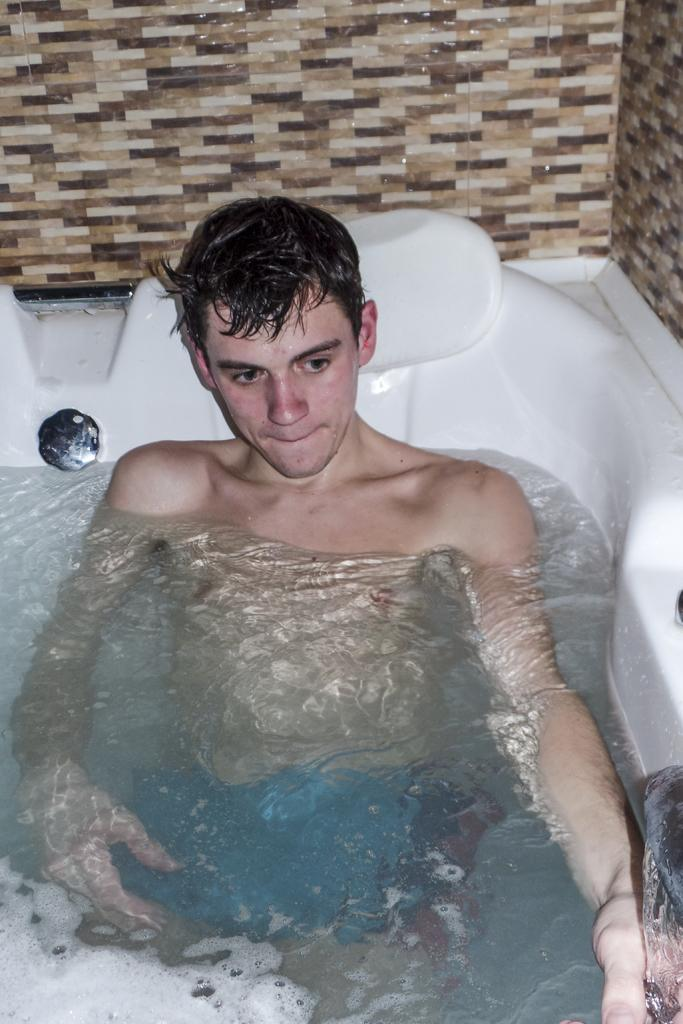Who or what is the main subject in the image? There is a person in the center of the image. What is the person doing or where are they located? The person is in a bath tub. What can be seen in the bath tub with the person? There is water in the bath tub. What is visible in the background of the image? There is a wall in the background of the image. What price is listed on the mailbox in the image? There is no mailbox present in the image, so there is no price listed. 